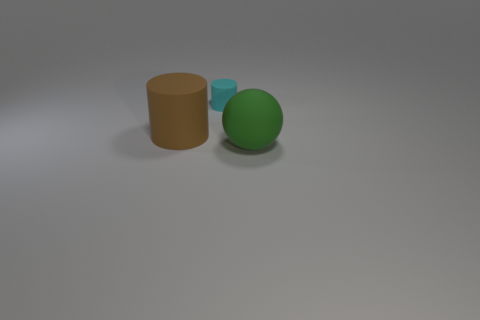Is the number of tiny cyan rubber things in front of the tiny cyan cylinder greater than the number of large brown cylinders that are behind the big rubber cylinder?
Provide a short and direct response. No. Is there any other thing that is the same color as the large cylinder?
Provide a short and direct response. No. Is there a large object left of the matte object that is on the right side of the cylinder behind the brown cylinder?
Keep it short and to the point. Yes. Do the large rubber thing that is right of the brown object and the big brown thing have the same shape?
Your response must be concise. No. Are there fewer small cyan cylinders that are in front of the cyan cylinder than large objects behind the big brown rubber cylinder?
Offer a terse response. No. What material is the green thing?
Offer a terse response. Rubber. There is a tiny rubber thing; does it have the same color as the big rubber object behind the big green ball?
Make the answer very short. No. What number of rubber cylinders are behind the large cylinder?
Offer a terse response. 1. Are there fewer large green things that are left of the large green object than tiny gray cubes?
Keep it short and to the point. No. The tiny rubber object has what color?
Your answer should be very brief. Cyan. 